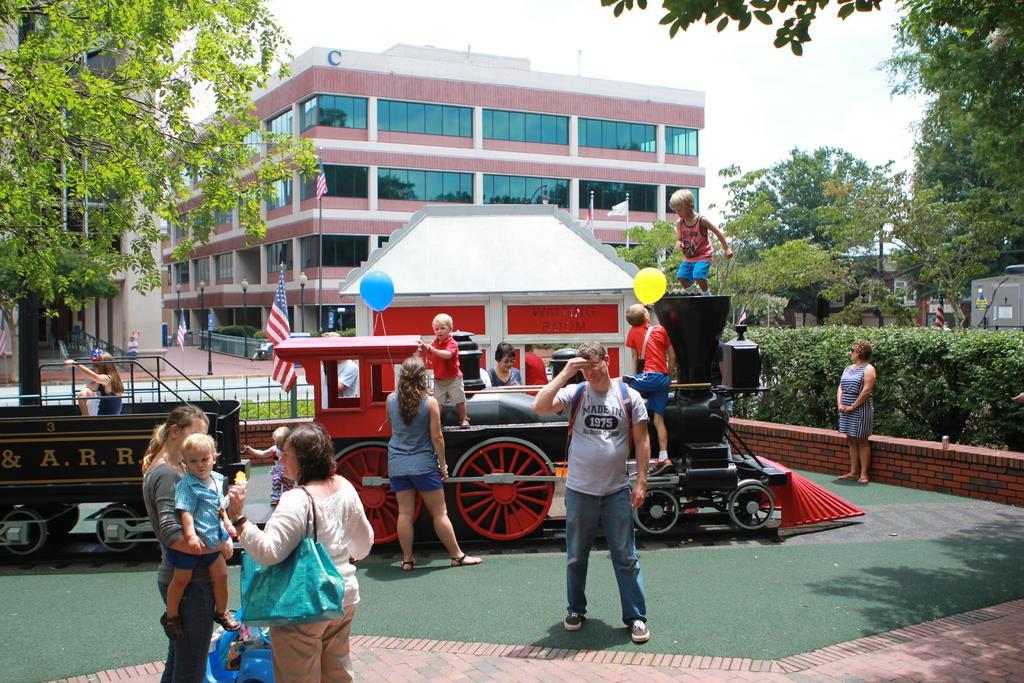How would you summarize this image in a sentence or two? In this image I can see group of people standing, the person in front is wearing white shirt, cream pant and green color bag, background I can see few balloons in multi color, flags in blue, red and white color, buildings in brown and white color, trees in green color and the sky is in white color. 